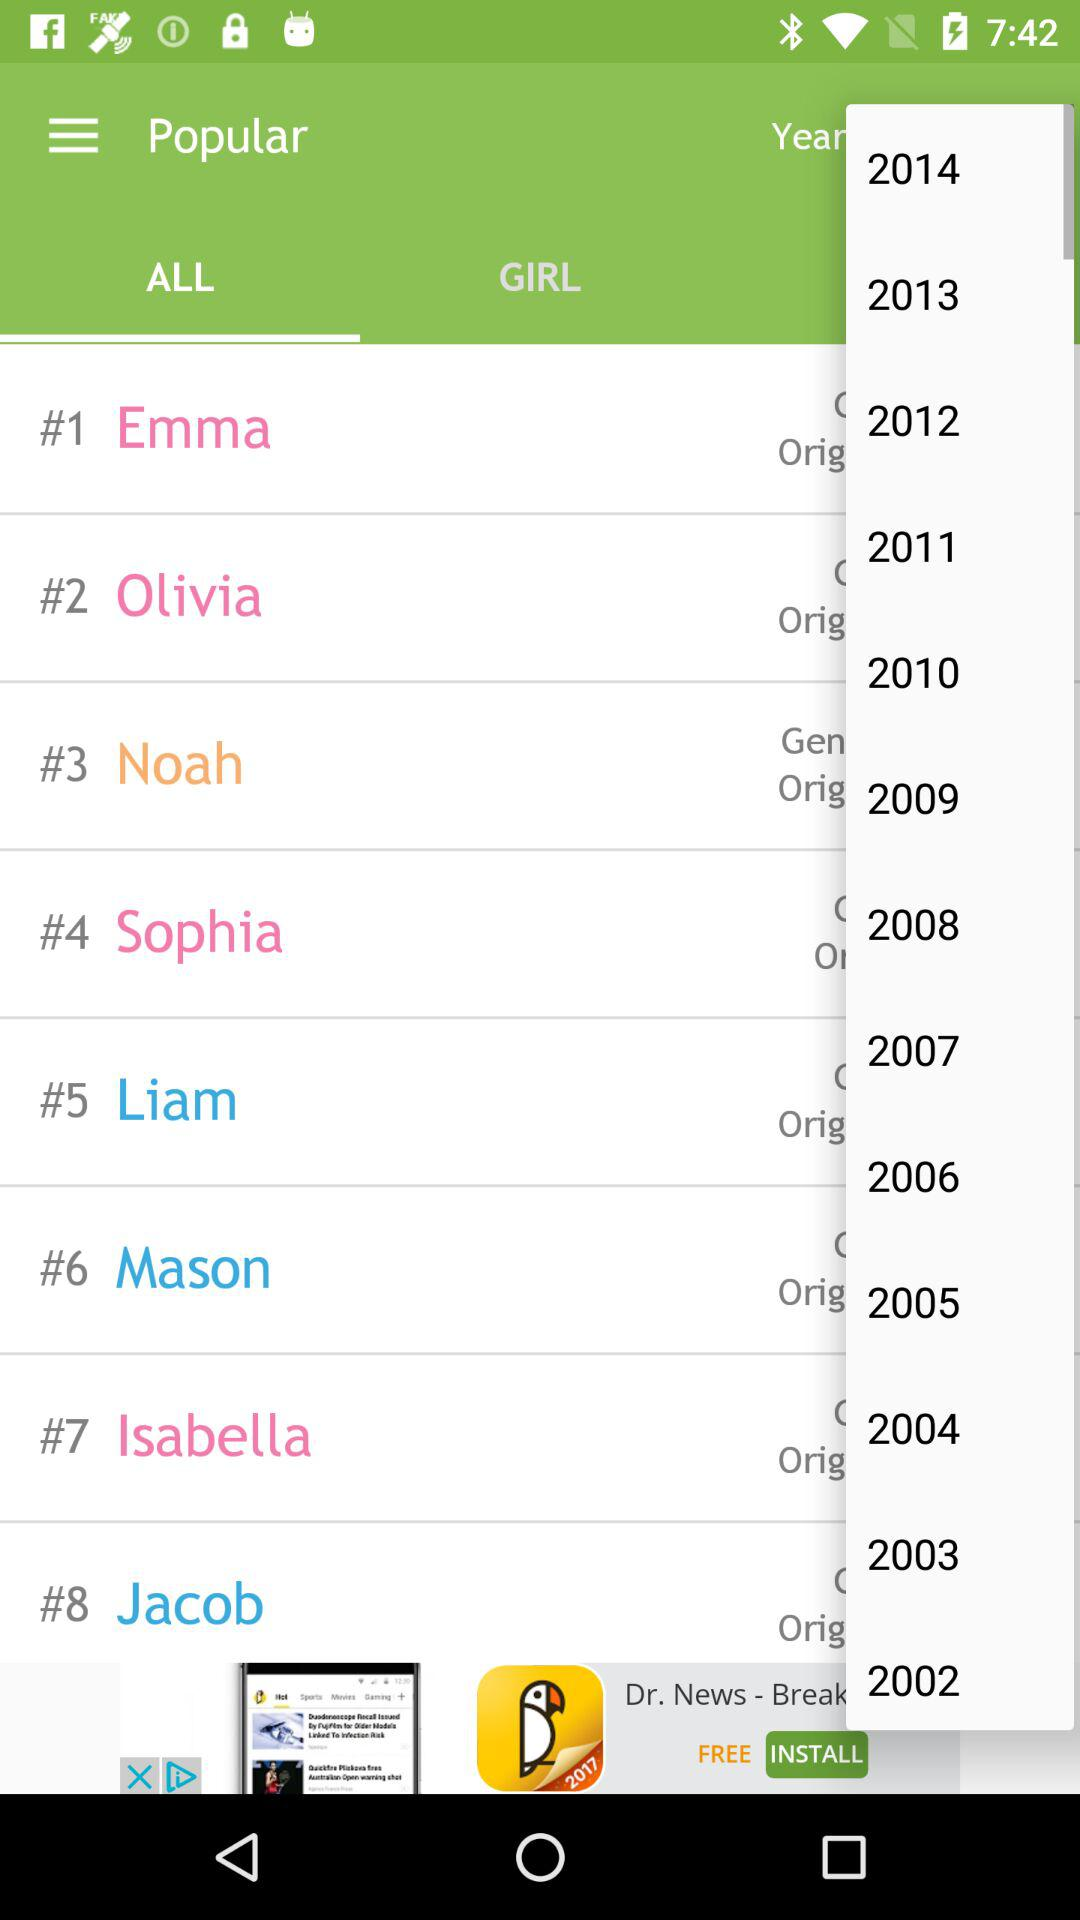Who occupied the first place on the popularity list? The first place on the popularity list is occupied by Emma. 